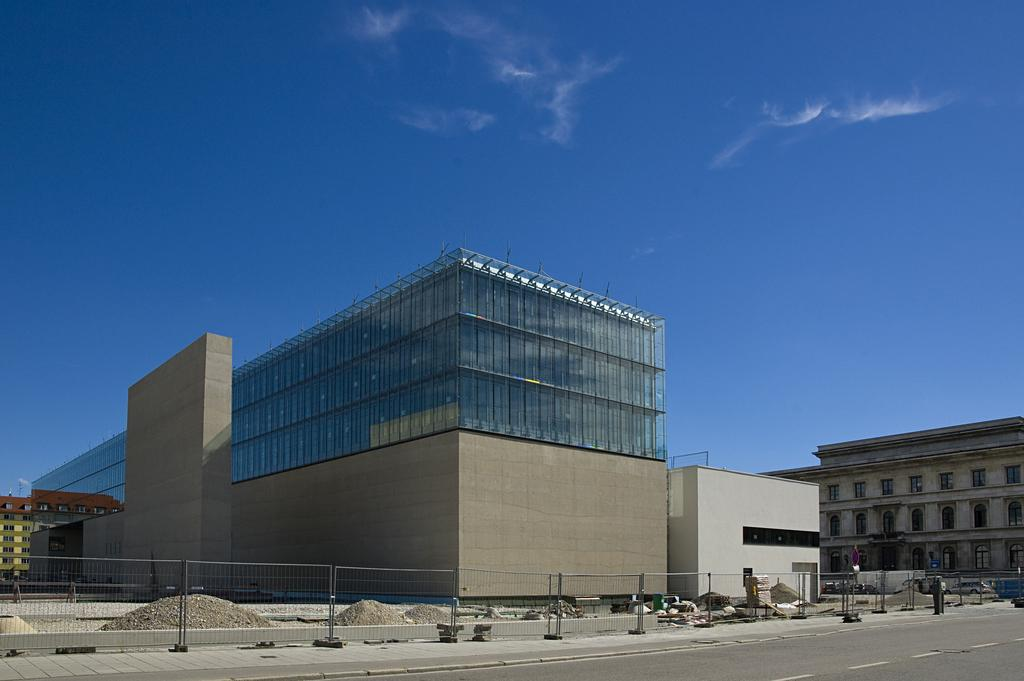What type of pathway is visible in the image? There is a road in the image. What can be seen alongside the road? There is fencing in the image. What structures are present in the image? There are buildings in the image. What is visible at the top of the image? The sky is visible at the top of the image, and it is clear. Where is the store located in the image? There is no store present in the image. What type of bomb can be seen in the image? There is no bomb present in the image. 